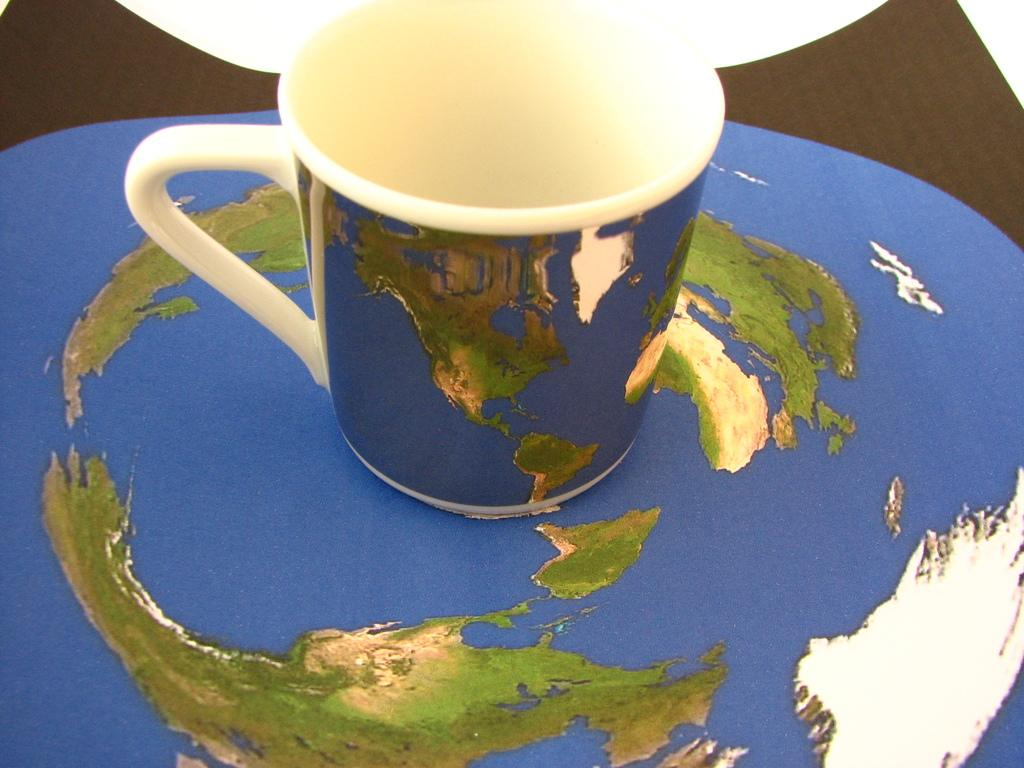What object can be seen in the image? There is a mug in the image. What is the level of pollution in the downtown area during the meeting depicted in the image? There is no information about pollution, downtown, or a meeting in the image; it only features a mug. 